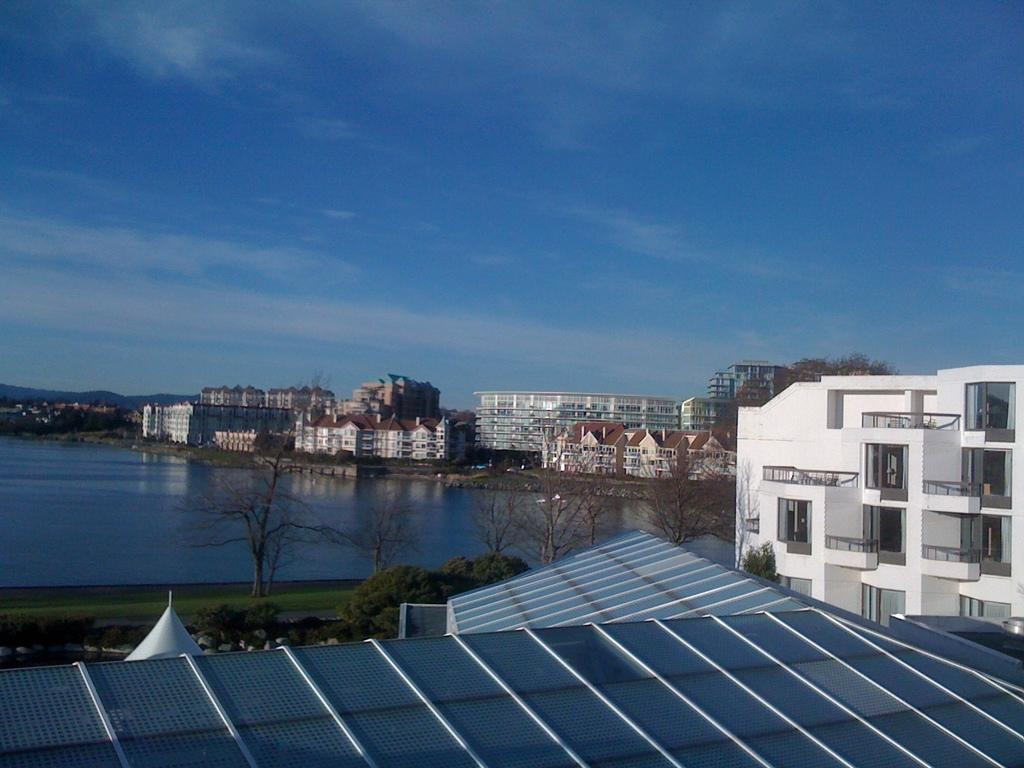What is the main subject of the image? The main subject of the image is a roof top. What type of structure is present in the image? There is a building in the image. What type of vegetation can be seen in the image? There are trees and grass visible in the image. What natural element is visible in the image? There is water visible in the image. What can be seen in the background of the image? There are buildings and the sky visible in the background of the image. How many beggars are visible on the roof top in the image? There are no beggars present in the image; it features a roof top, building, trees, grass, water, and a background with buildings and the sky. What type of trees can be seen interacting with the cook in the image? There is no cook or interaction with trees present in the image. 